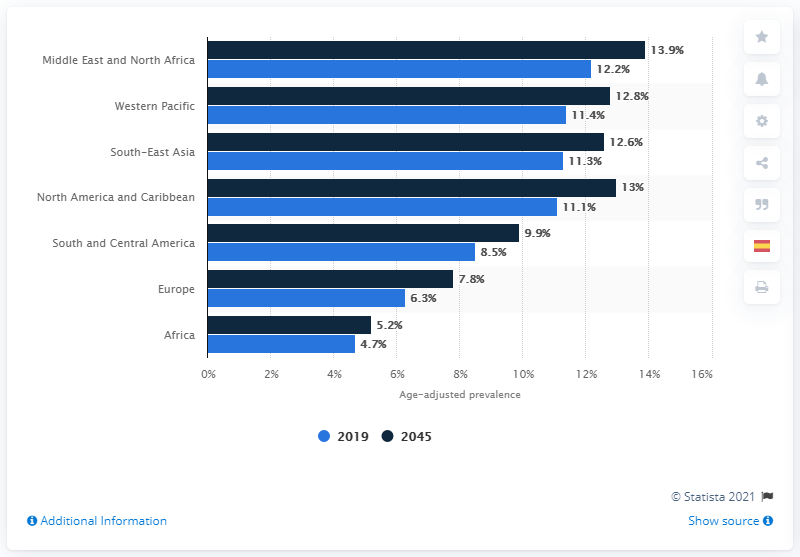Mention a couple of crucial points in this snapshot. The age-adjusted diabetes prevalence is forecasted to be in 2045. 